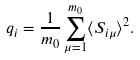Convert formula to latex. <formula><loc_0><loc_0><loc_500><loc_500>q _ { i } = \frac { 1 } { m _ { 0 } } \sum _ { \mu = 1 } ^ { m _ { 0 } } \langle S _ { i \mu } \rangle ^ { 2 } .</formula> 